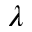Convert formula to latex. <formula><loc_0><loc_0><loc_500><loc_500>\lambda</formula> 